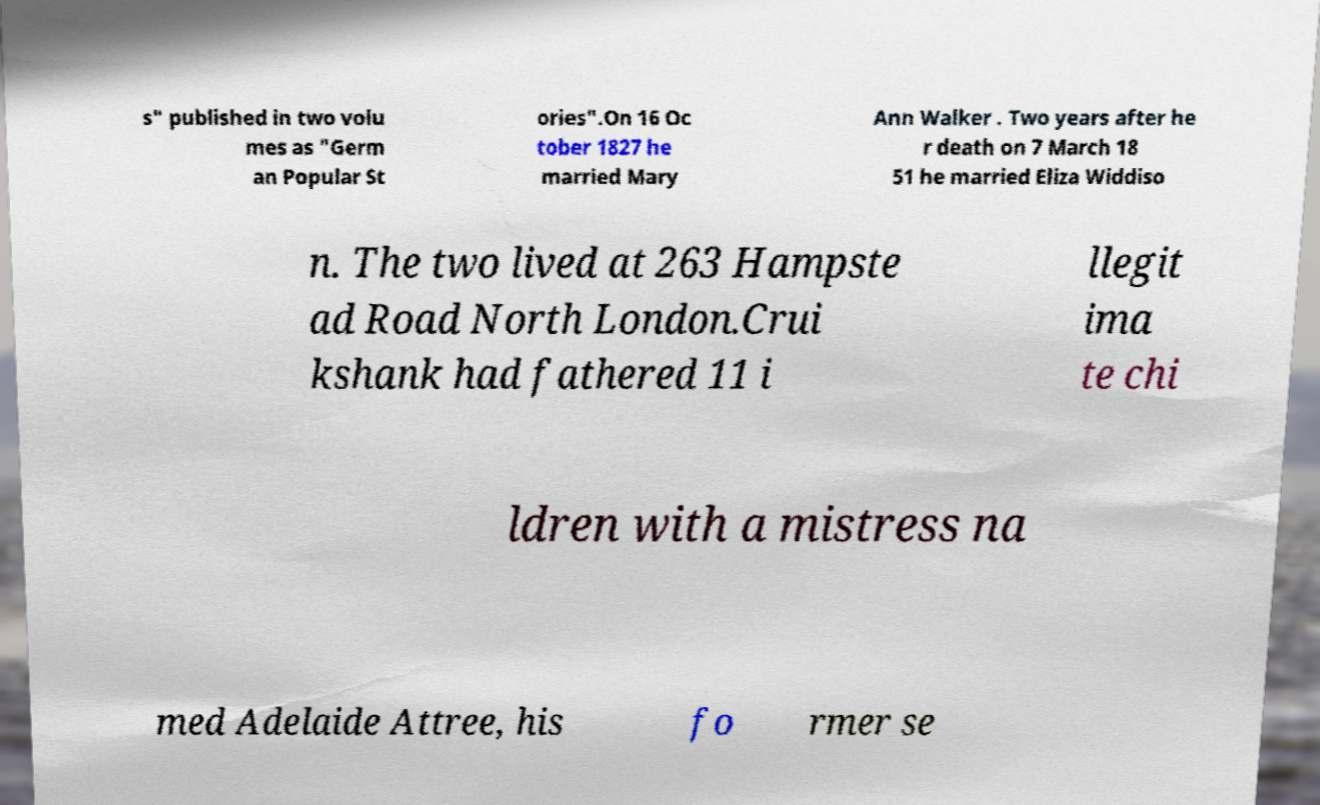Please identify and transcribe the text found in this image. s" published in two volu mes as "Germ an Popular St ories".On 16 Oc tober 1827 he married Mary Ann Walker . Two years after he r death on 7 March 18 51 he married Eliza Widdiso n. The two lived at 263 Hampste ad Road North London.Crui kshank had fathered 11 i llegit ima te chi ldren with a mistress na med Adelaide Attree, his fo rmer se 